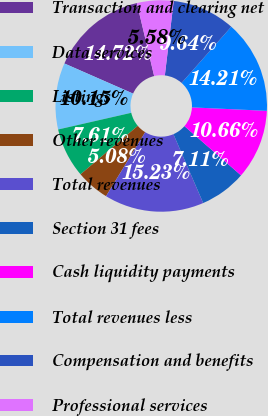Convert chart to OTSL. <chart><loc_0><loc_0><loc_500><loc_500><pie_chart><fcel>Transaction and clearing net<fcel>Data services<fcel>Listings<fcel>Other revenues<fcel>Total revenues<fcel>Section 31 fees<fcel>Cash liquidity payments<fcel>Total revenues less<fcel>Compensation and benefits<fcel>Professional services<nl><fcel>14.72%<fcel>10.15%<fcel>7.61%<fcel>5.08%<fcel>15.23%<fcel>7.11%<fcel>10.66%<fcel>14.21%<fcel>9.64%<fcel>5.58%<nl></chart> 